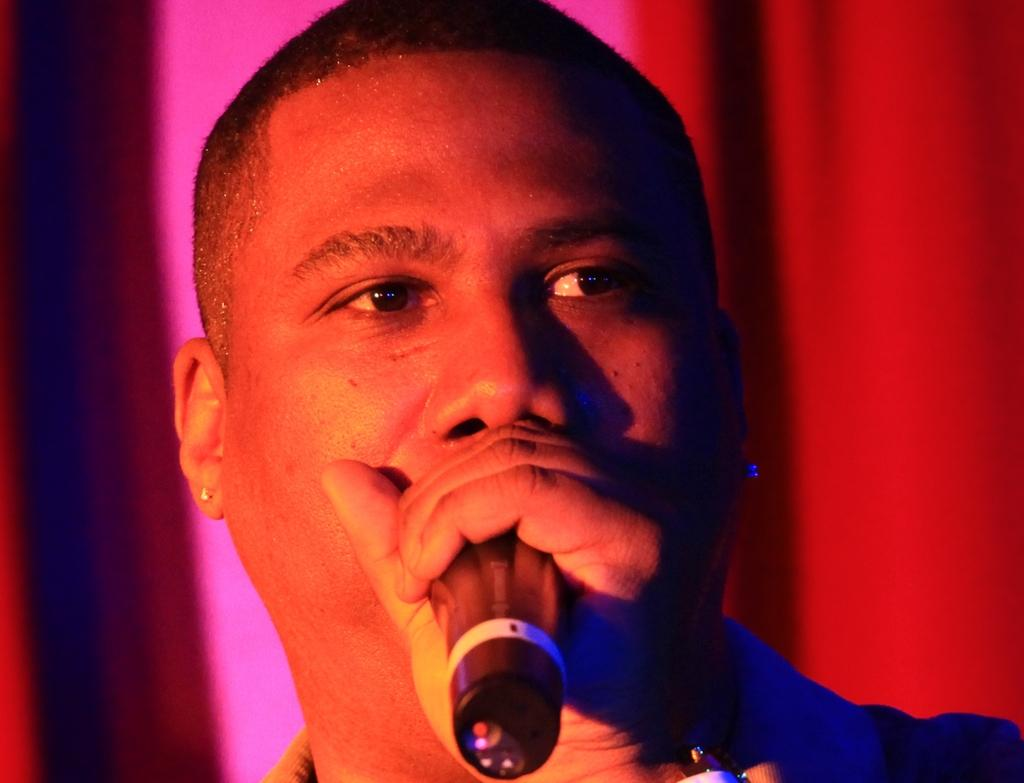Who is the main subject in the image? There is a man in the image. What is the man holding in the image? The man is holding a microphone. What is the man doing with the microphone? The man is speaking into the microphone. Can you see any dolls playing on the seashore in the image? There is no seashore or dolls present in the image; it features a man holding and speaking into a microphone. 